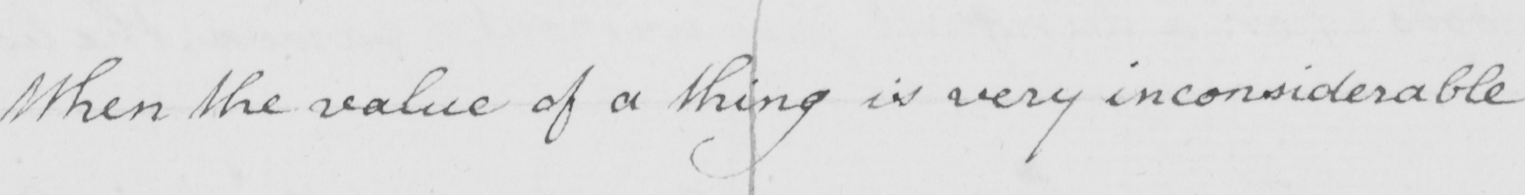What text is written in this handwritten line? When the value of a thing is very inconsiderable 